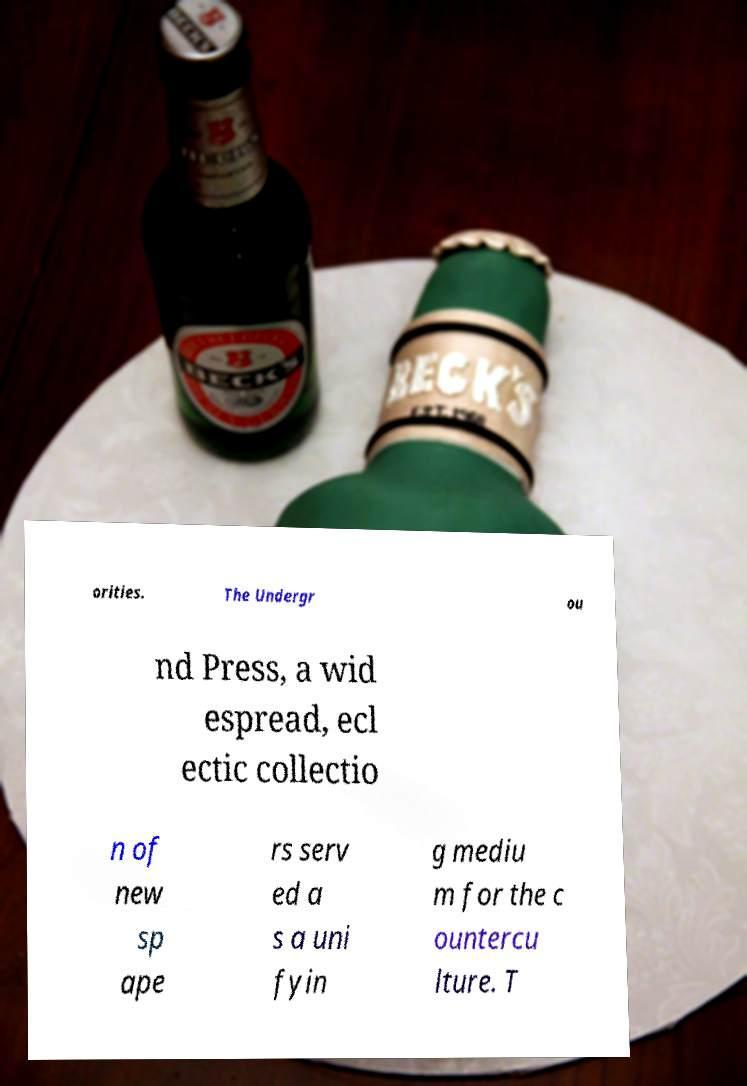For documentation purposes, I need the text within this image transcribed. Could you provide that? orities. The Undergr ou nd Press, a wid espread, ecl ectic collectio n of new sp ape rs serv ed a s a uni fyin g mediu m for the c ountercu lture. T 